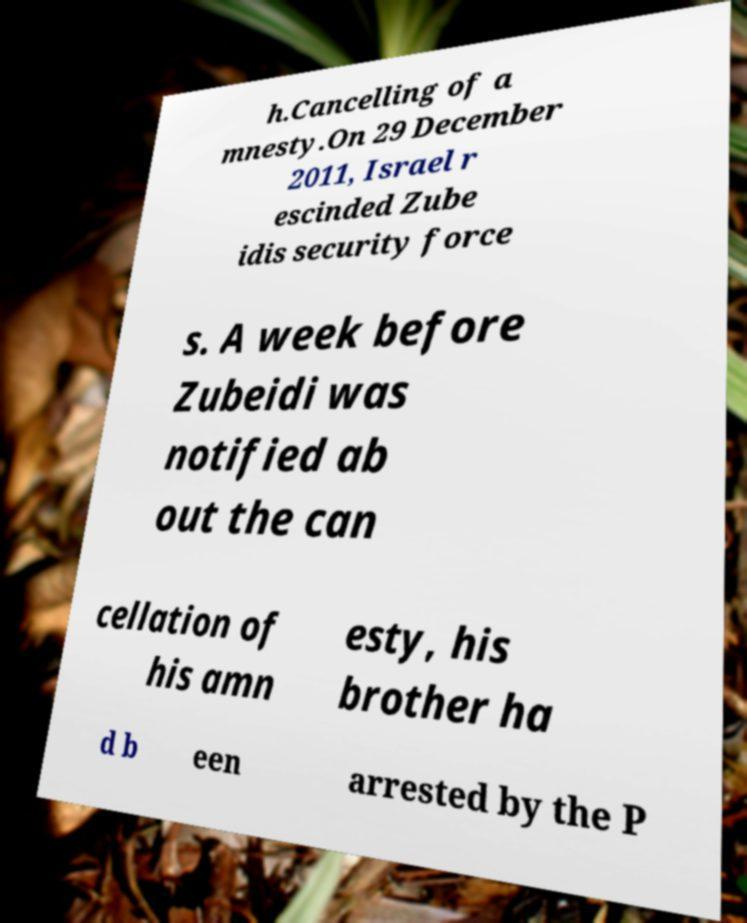Please identify and transcribe the text found in this image. h.Cancelling of a mnesty.On 29 December 2011, Israel r escinded Zube idis security force s. A week before Zubeidi was notified ab out the can cellation of his amn esty, his brother ha d b een arrested by the P 